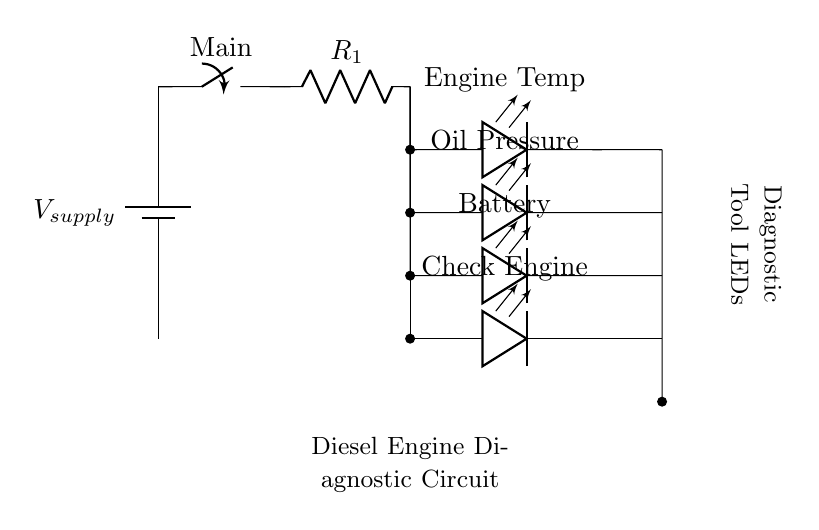What is the main function of the switch? The switch is used to control the flow of current in the circuit. When the switch is in the closed position, it allows current to flow from the power supply to the resistor and subsequently to the LEDs.
Answer: control current flow How many LEDs are present in the circuit? The circuit diagram shows four distinct LEDs connected in parallel, representing different system statuses for the diesel engine.
Answer: four What do the LEDs indicate? Each LED corresponds to a specific diagnostic status: Engine Temperature, Oil Pressure, Battery, and Check Engine, providing visual feedback on those conditions in the engine.
Answer: diagnostic statuses What is the purpose of the resistor in the circuit? The resistor limits the current flowing through the LEDs to prevent them from drawing too much current and burning out, ensuring they operate safely and correctly.
Answer: limit current Describe the configuration of the LEDs. The LEDs are connected in parallel, which means they share the same voltage source but can light up independently based on their respective conditions.
Answer: parallel configuration Which LED is at the highest position in the diagram? The Engine Temperature LED is the highest positioned in the circuit diagram, indicating it is the first component in the vertical arrangement of the parallel LEDs.
Answer: Engine Temperature Which component supplies power to the circuit? The power source is indicated by the battery symbol in the circuit diagram, which provides the necessary voltage for the operation of the entire circuit.
Answer: battery 